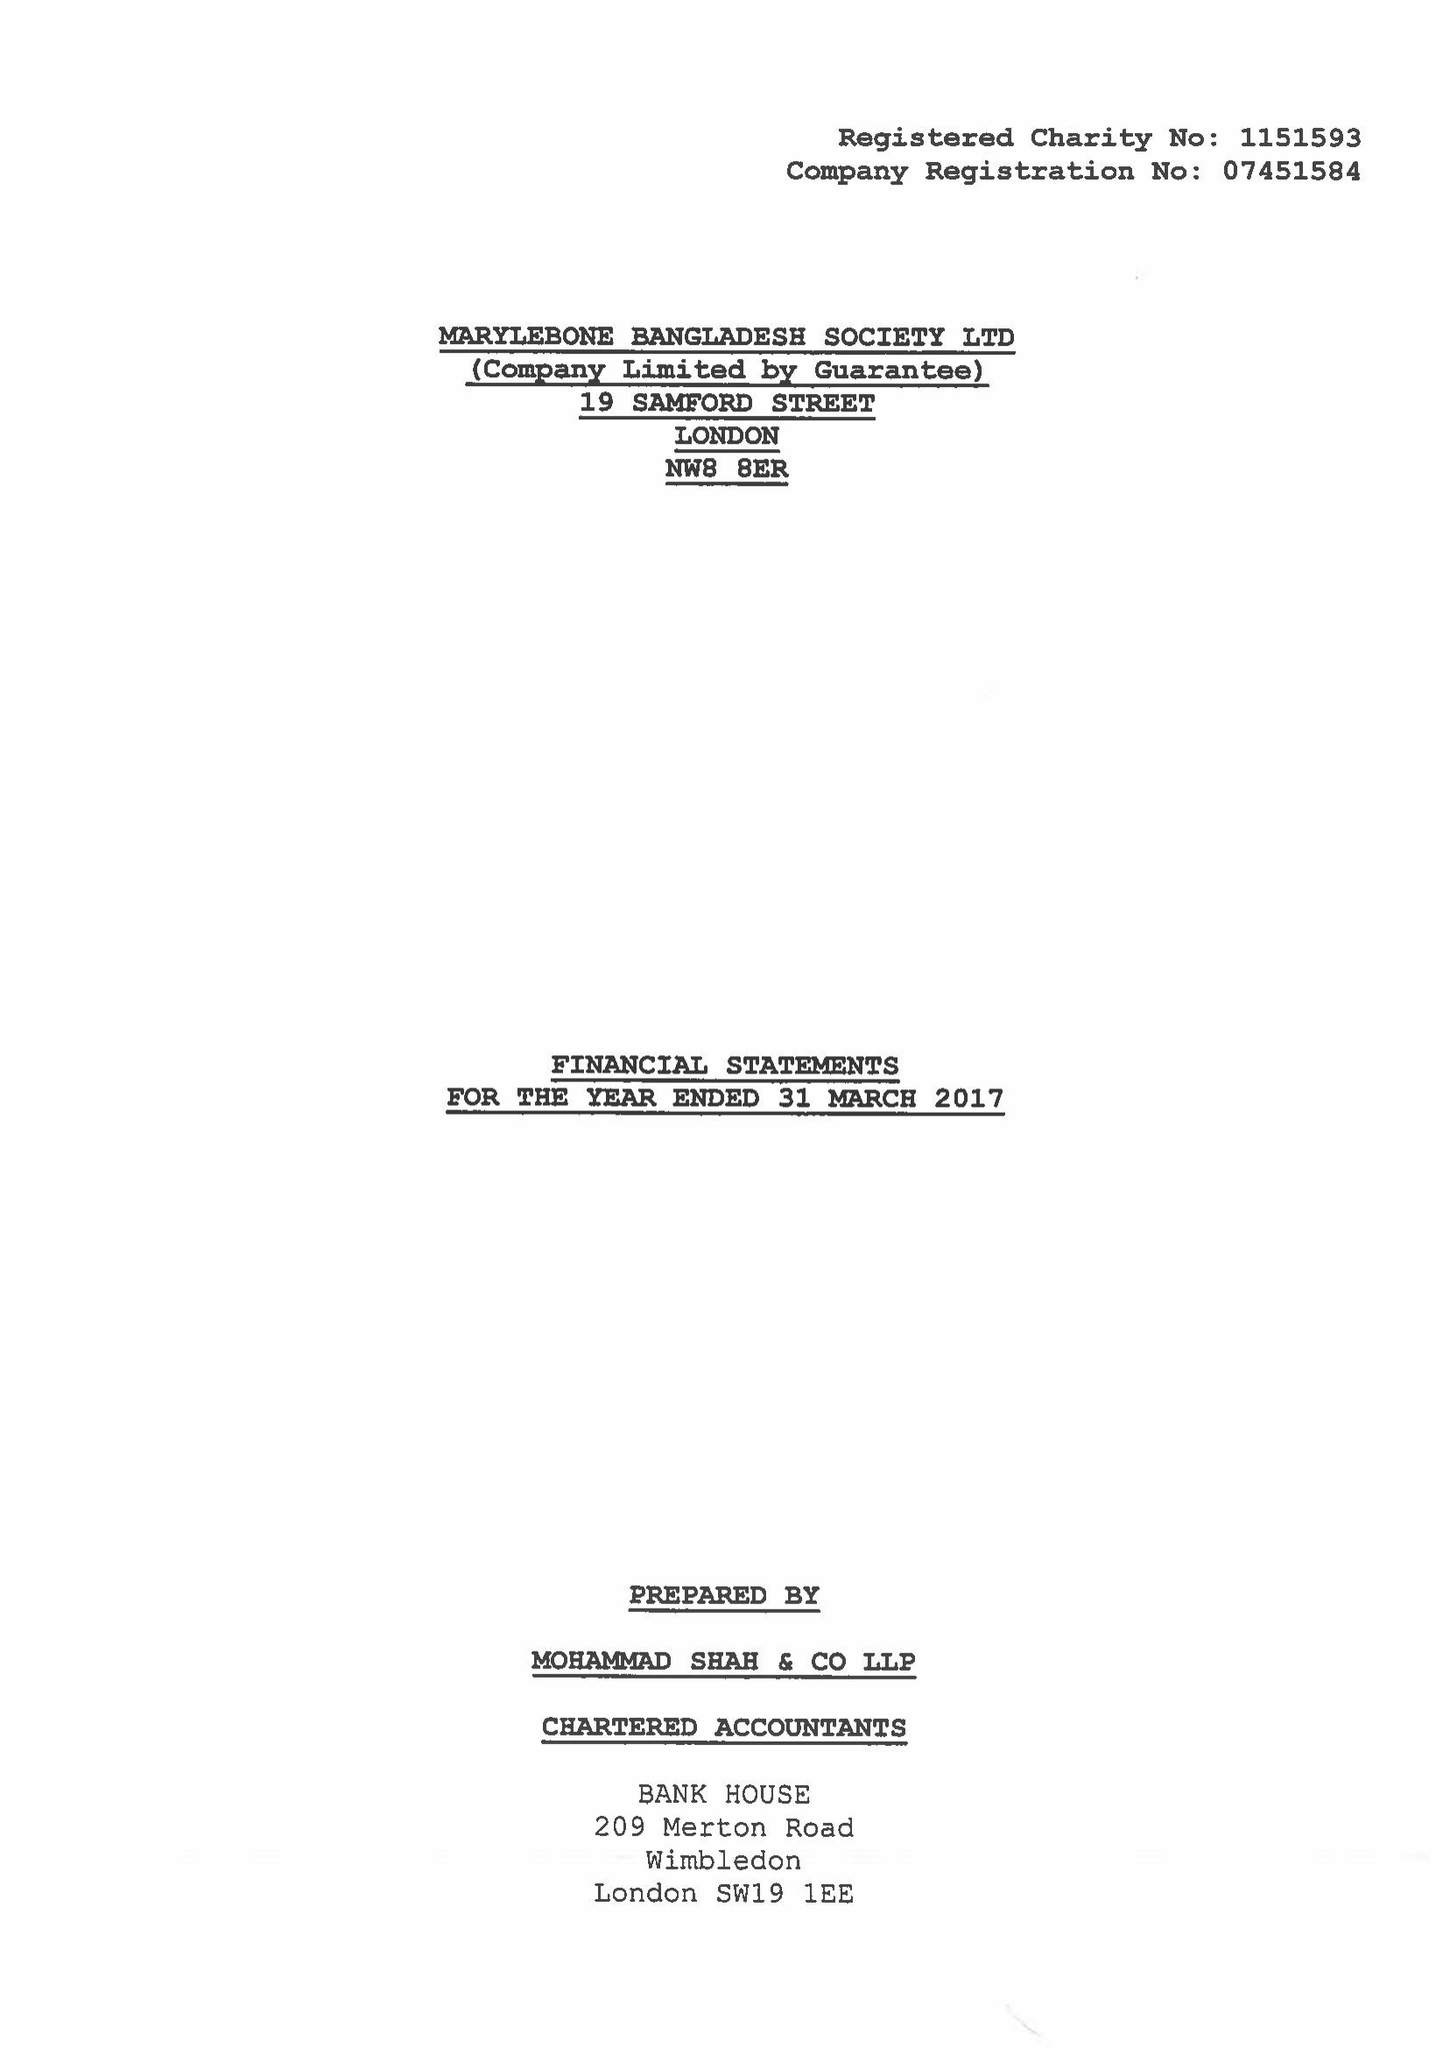What is the value for the charity_number?
Answer the question using a single word or phrase. 1151593 